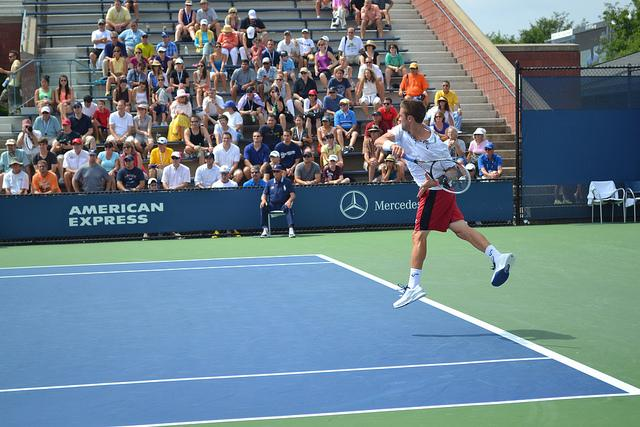Which company has sponsored this event?

Choices:
A) american express
B) bmw
C) sony
D) visa american express 